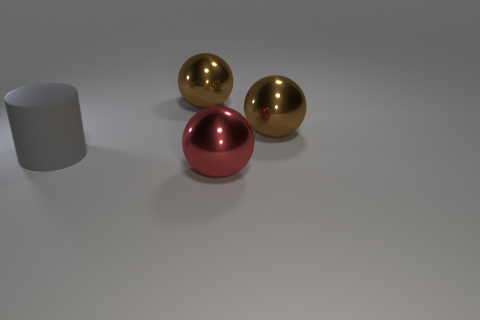What materials do the spheres seem to be made of? The two spheres on the right appear to have a reflective surface similar to polished metal, potentially indicative of gold or a gold-like material. The sphere on the left has a similar reflective quality with a red hue, suggesting it might be a metallic material with a red coating or treatment. Can you estimate the size of these spheres? While it's challenging to estimate the exact size without a reference object, they seem to be roughly the size of a small melon or large grapefruit, with a diameter that could be around 10 to 15 centimeters. 